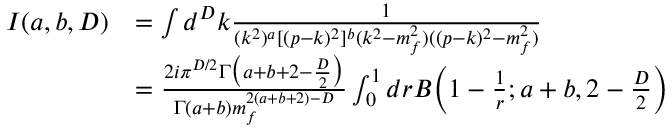Convert formula to latex. <formula><loc_0><loc_0><loc_500><loc_500>\begin{array} { r l } { I ( a , b , D ) } & { = \int d ^ { D } k \frac { 1 } { ( k ^ { 2 } ) ^ { a } [ ( p - k ) ^ { 2 } ] ^ { b } ( k ^ { 2 } - m _ { f } ^ { 2 } ) ( ( p - k ) ^ { 2 } - m _ { f } ^ { 2 } ) } } \\ & { = \frac { 2 i \pi ^ { D / 2 } \Gamma \left ( a + b + 2 - \frac { D } { 2 } \right ) } { \Gamma ( a + b ) m _ { f } ^ { 2 ( a + b + 2 ) - D } } \int _ { 0 } ^ { 1 } d r B \left ( 1 - \frac { 1 } { r } ; a + b , 2 - \frac { D } { 2 } \right ) } \end{array}</formula> 